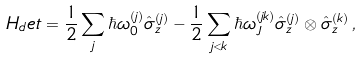Convert formula to latex. <formula><loc_0><loc_0><loc_500><loc_500>H _ { d } e t = \frac { 1 } { 2 } \sum _ { j } \hbar { \omega } _ { 0 } ^ { ( j ) } \hat { \sigma } _ { z } ^ { ( j ) } - \frac { 1 } { 2 } \sum _ { j < k } \hbar { \omega } _ { J } ^ { ( j k ) } \hat { \sigma } _ { z } ^ { ( j ) } \otimes \hat { \sigma } _ { z } ^ { ( k ) } \, ,</formula> 